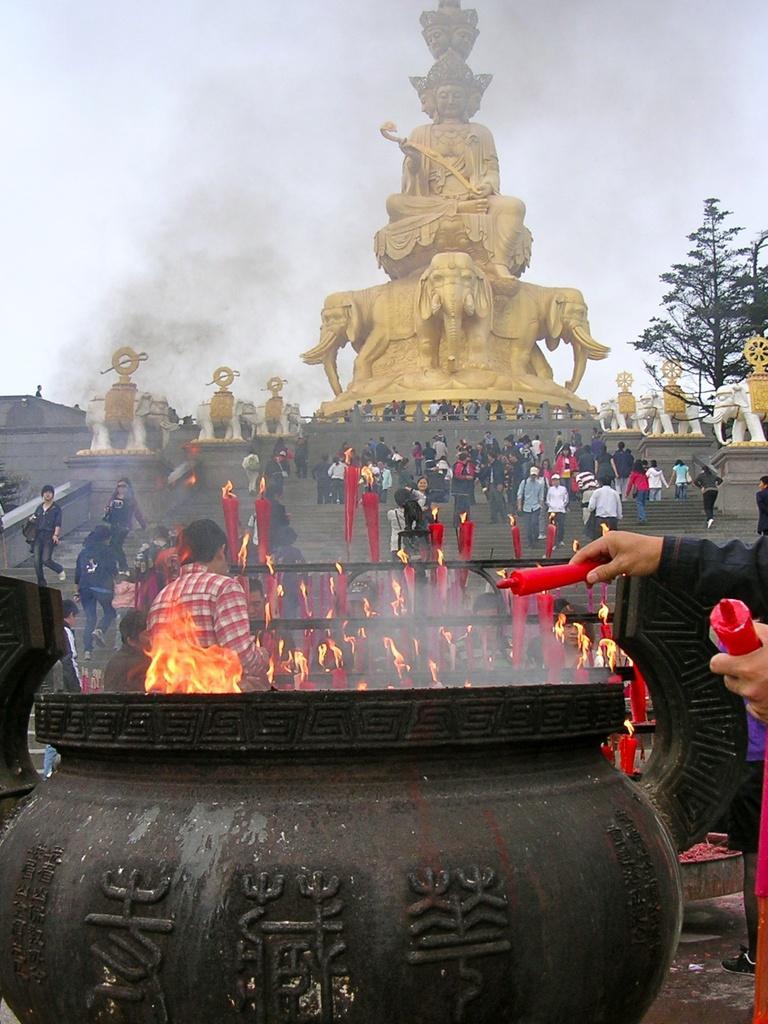Describe this image in one or two sentences. In this picture there is a big utensil at the bottom side of the image and there are people and fire flags in the center of the image and there is a statue and a tree at the top side of the image. 